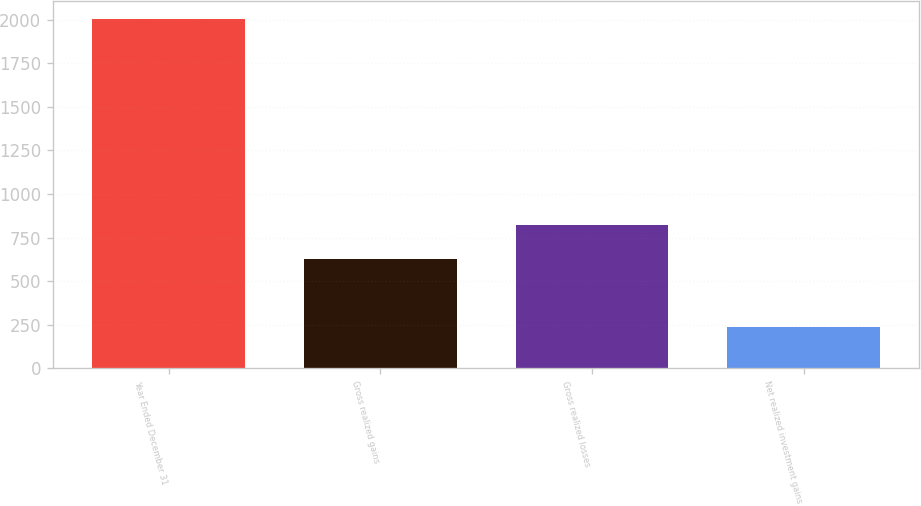Convert chart. <chart><loc_0><loc_0><loc_500><loc_500><bar_chart><fcel>Year Ended December 31<fcel>Gross realized gains<fcel>Gross realized losses<fcel>Net realized investment gains<nl><fcel>2005<fcel>628.1<fcel>824.8<fcel>234.7<nl></chart> 